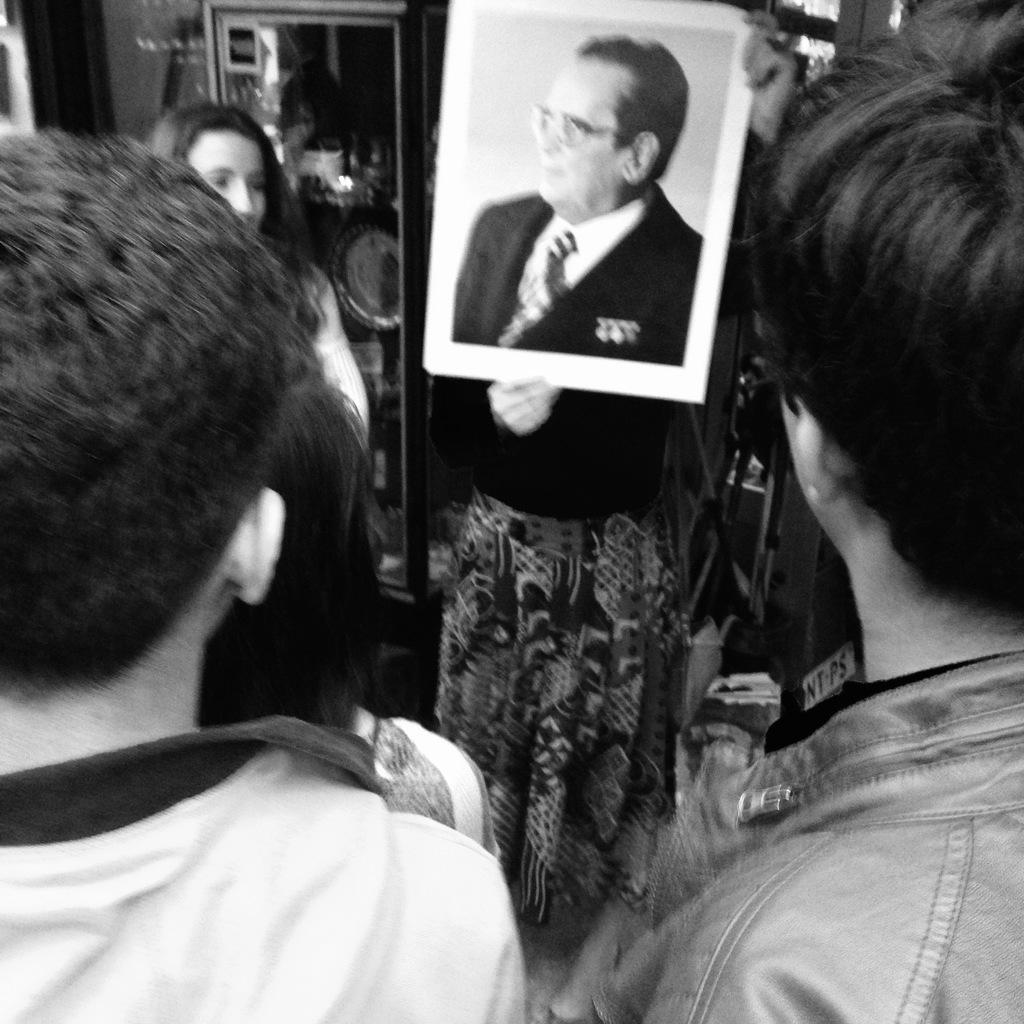Can you describe this image briefly? In this picture we can see a group of people, one person is holding a photo of a poster and in the background we can see a mirror, wall and some objects. 